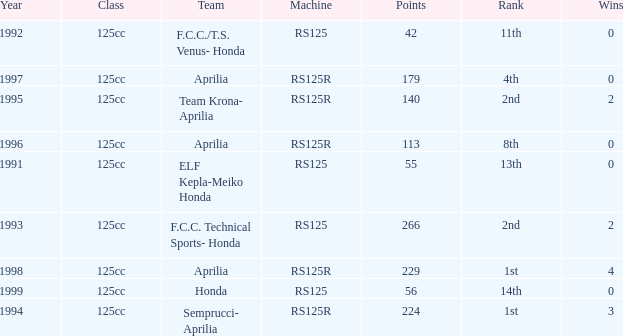Which year had a team of Aprilia and a rank of 4th? 1997.0. 